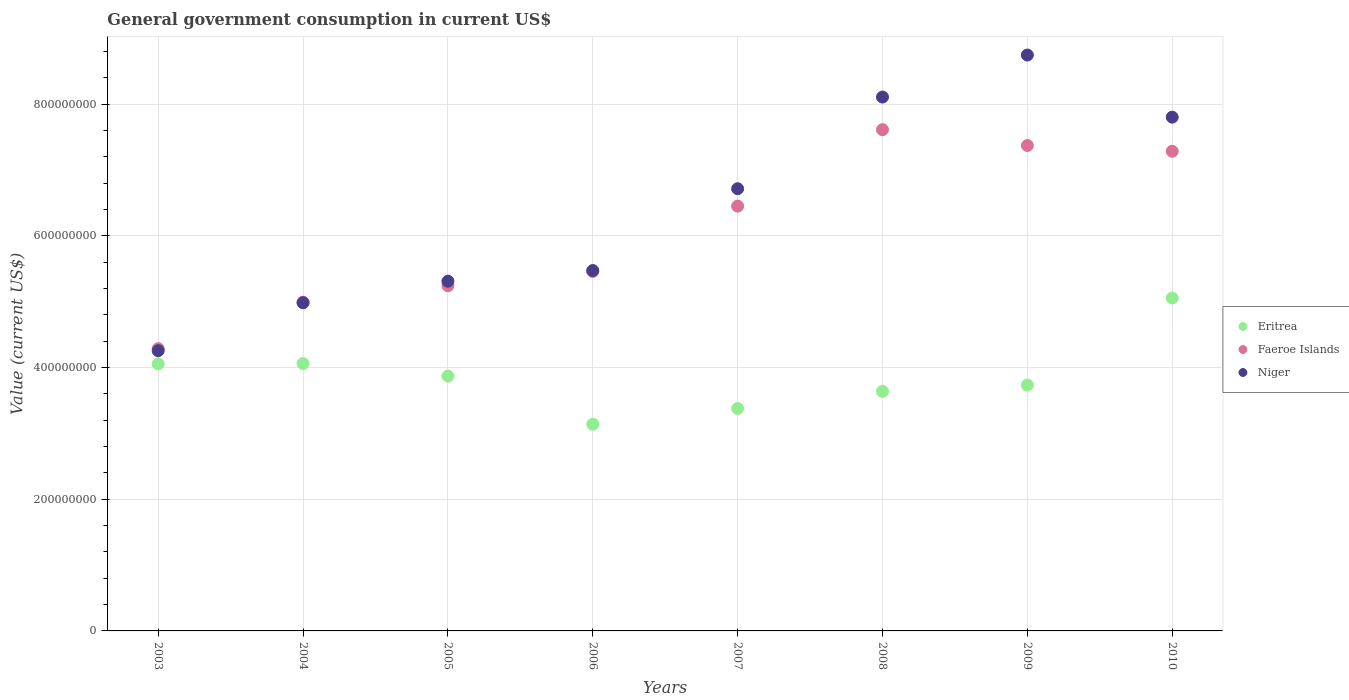Is the number of dotlines equal to the number of legend labels?
Your response must be concise. Yes. What is the government conusmption in Eritrea in 2005?
Provide a short and direct response. 3.87e+08. Across all years, what is the maximum government conusmption in Faeroe Islands?
Your response must be concise. 7.61e+08. Across all years, what is the minimum government conusmption in Eritrea?
Give a very brief answer. 3.14e+08. In which year was the government conusmption in Eritrea maximum?
Offer a terse response. 2010. In which year was the government conusmption in Faeroe Islands minimum?
Provide a succinct answer. 2003. What is the total government conusmption in Faeroe Islands in the graph?
Your response must be concise. 4.87e+09. What is the difference between the government conusmption in Niger in 2004 and that in 2008?
Keep it short and to the point. -3.12e+08. What is the difference between the government conusmption in Faeroe Islands in 2006 and the government conusmption in Niger in 2003?
Ensure brevity in your answer.  1.20e+08. What is the average government conusmption in Faeroe Islands per year?
Provide a short and direct response. 6.09e+08. In the year 2008, what is the difference between the government conusmption in Eritrea and government conusmption in Faeroe Islands?
Provide a succinct answer. -3.97e+08. In how many years, is the government conusmption in Niger greater than 320000000 US$?
Make the answer very short. 8. What is the ratio of the government conusmption in Niger in 2006 to that in 2008?
Make the answer very short. 0.68. What is the difference between the highest and the second highest government conusmption in Eritrea?
Provide a short and direct response. 9.95e+07. What is the difference between the highest and the lowest government conusmption in Niger?
Your answer should be very brief. 4.49e+08. In how many years, is the government conusmption in Eritrea greater than the average government conusmption in Eritrea taken over all years?
Give a very brief answer. 4. Is the sum of the government conusmption in Niger in 2003 and 2008 greater than the maximum government conusmption in Faeroe Islands across all years?
Offer a very short reply. Yes. Is the government conusmption in Faeroe Islands strictly greater than the government conusmption in Niger over the years?
Ensure brevity in your answer.  No. How many years are there in the graph?
Keep it short and to the point. 8. What is the difference between two consecutive major ticks on the Y-axis?
Provide a succinct answer. 2.00e+08. Are the values on the major ticks of Y-axis written in scientific E-notation?
Provide a succinct answer. No. Does the graph contain any zero values?
Offer a very short reply. No. How many legend labels are there?
Offer a very short reply. 3. What is the title of the graph?
Ensure brevity in your answer.  General government consumption in current US$. What is the label or title of the X-axis?
Make the answer very short. Years. What is the label or title of the Y-axis?
Offer a very short reply. Value (current US$). What is the Value (current US$) of Eritrea in 2003?
Keep it short and to the point. 4.06e+08. What is the Value (current US$) of Faeroe Islands in 2003?
Your answer should be very brief. 4.29e+08. What is the Value (current US$) of Niger in 2003?
Keep it short and to the point. 4.26e+08. What is the Value (current US$) of Eritrea in 2004?
Offer a terse response. 4.06e+08. What is the Value (current US$) of Faeroe Islands in 2004?
Offer a very short reply. 4.99e+08. What is the Value (current US$) of Niger in 2004?
Offer a very short reply. 4.98e+08. What is the Value (current US$) of Eritrea in 2005?
Provide a succinct answer. 3.87e+08. What is the Value (current US$) in Faeroe Islands in 2005?
Provide a short and direct response. 5.24e+08. What is the Value (current US$) in Niger in 2005?
Your answer should be very brief. 5.31e+08. What is the Value (current US$) in Eritrea in 2006?
Give a very brief answer. 3.14e+08. What is the Value (current US$) in Faeroe Islands in 2006?
Offer a terse response. 5.46e+08. What is the Value (current US$) in Niger in 2006?
Your answer should be very brief. 5.47e+08. What is the Value (current US$) in Eritrea in 2007?
Your answer should be compact. 3.38e+08. What is the Value (current US$) of Faeroe Islands in 2007?
Your answer should be very brief. 6.45e+08. What is the Value (current US$) in Niger in 2007?
Your answer should be compact. 6.72e+08. What is the Value (current US$) of Eritrea in 2008?
Your answer should be very brief. 3.64e+08. What is the Value (current US$) in Faeroe Islands in 2008?
Ensure brevity in your answer.  7.61e+08. What is the Value (current US$) in Niger in 2008?
Keep it short and to the point. 8.11e+08. What is the Value (current US$) in Eritrea in 2009?
Offer a very short reply. 3.73e+08. What is the Value (current US$) of Faeroe Islands in 2009?
Provide a short and direct response. 7.37e+08. What is the Value (current US$) in Niger in 2009?
Your response must be concise. 8.75e+08. What is the Value (current US$) in Eritrea in 2010?
Give a very brief answer. 5.06e+08. What is the Value (current US$) of Faeroe Islands in 2010?
Provide a succinct answer. 7.28e+08. What is the Value (current US$) in Niger in 2010?
Offer a terse response. 7.80e+08. Across all years, what is the maximum Value (current US$) of Eritrea?
Give a very brief answer. 5.06e+08. Across all years, what is the maximum Value (current US$) in Faeroe Islands?
Ensure brevity in your answer.  7.61e+08. Across all years, what is the maximum Value (current US$) of Niger?
Your answer should be compact. 8.75e+08. Across all years, what is the minimum Value (current US$) in Eritrea?
Offer a very short reply. 3.14e+08. Across all years, what is the minimum Value (current US$) in Faeroe Islands?
Your answer should be compact. 4.29e+08. Across all years, what is the minimum Value (current US$) in Niger?
Keep it short and to the point. 4.26e+08. What is the total Value (current US$) of Eritrea in the graph?
Your answer should be compact. 3.09e+09. What is the total Value (current US$) of Faeroe Islands in the graph?
Your answer should be compact. 4.87e+09. What is the total Value (current US$) of Niger in the graph?
Your answer should be very brief. 5.14e+09. What is the difference between the Value (current US$) in Eritrea in 2003 and that in 2004?
Give a very brief answer. -4.90e+05. What is the difference between the Value (current US$) of Faeroe Islands in 2003 and that in 2004?
Give a very brief answer. -7.06e+07. What is the difference between the Value (current US$) of Niger in 2003 and that in 2004?
Provide a short and direct response. -7.28e+07. What is the difference between the Value (current US$) in Eritrea in 2003 and that in 2005?
Offer a terse response. 1.85e+07. What is the difference between the Value (current US$) in Faeroe Islands in 2003 and that in 2005?
Provide a short and direct response. -9.56e+07. What is the difference between the Value (current US$) in Niger in 2003 and that in 2005?
Your response must be concise. -1.06e+08. What is the difference between the Value (current US$) in Eritrea in 2003 and that in 2006?
Offer a terse response. 9.16e+07. What is the difference between the Value (current US$) in Faeroe Islands in 2003 and that in 2006?
Your response must be concise. -1.17e+08. What is the difference between the Value (current US$) in Niger in 2003 and that in 2006?
Your answer should be very brief. -1.22e+08. What is the difference between the Value (current US$) of Eritrea in 2003 and that in 2007?
Provide a short and direct response. 6.77e+07. What is the difference between the Value (current US$) in Faeroe Islands in 2003 and that in 2007?
Provide a short and direct response. -2.16e+08. What is the difference between the Value (current US$) of Niger in 2003 and that in 2007?
Give a very brief answer. -2.46e+08. What is the difference between the Value (current US$) of Eritrea in 2003 and that in 2008?
Offer a terse response. 4.17e+07. What is the difference between the Value (current US$) in Faeroe Islands in 2003 and that in 2008?
Make the answer very short. -3.33e+08. What is the difference between the Value (current US$) in Niger in 2003 and that in 2008?
Your response must be concise. -3.85e+08. What is the difference between the Value (current US$) in Eritrea in 2003 and that in 2009?
Offer a terse response. 3.21e+07. What is the difference between the Value (current US$) in Faeroe Islands in 2003 and that in 2009?
Ensure brevity in your answer.  -3.09e+08. What is the difference between the Value (current US$) of Niger in 2003 and that in 2009?
Your response must be concise. -4.49e+08. What is the difference between the Value (current US$) of Eritrea in 2003 and that in 2010?
Offer a terse response. -1.00e+08. What is the difference between the Value (current US$) of Faeroe Islands in 2003 and that in 2010?
Give a very brief answer. -3.00e+08. What is the difference between the Value (current US$) in Niger in 2003 and that in 2010?
Offer a terse response. -3.55e+08. What is the difference between the Value (current US$) in Eritrea in 2004 and that in 2005?
Provide a succinct answer. 1.90e+07. What is the difference between the Value (current US$) of Faeroe Islands in 2004 and that in 2005?
Your answer should be compact. -2.50e+07. What is the difference between the Value (current US$) in Niger in 2004 and that in 2005?
Provide a succinct answer. -3.27e+07. What is the difference between the Value (current US$) in Eritrea in 2004 and that in 2006?
Ensure brevity in your answer.  9.21e+07. What is the difference between the Value (current US$) in Faeroe Islands in 2004 and that in 2006?
Your response must be concise. -4.68e+07. What is the difference between the Value (current US$) of Niger in 2004 and that in 2006?
Give a very brief answer. -4.89e+07. What is the difference between the Value (current US$) of Eritrea in 2004 and that in 2007?
Your response must be concise. 6.82e+07. What is the difference between the Value (current US$) in Faeroe Islands in 2004 and that in 2007?
Your answer should be compact. -1.46e+08. What is the difference between the Value (current US$) in Niger in 2004 and that in 2007?
Your response must be concise. -1.73e+08. What is the difference between the Value (current US$) in Eritrea in 2004 and that in 2008?
Offer a very short reply. 4.22e+07. What is the difference between the Value (current US$) of Faeroe Islands in 2004 and that in 2008?
Give a very brief answer. -2.62e+08. What is the difference between the Value (current US$) in Niger in 2004 and that in 2008?
Offer a terse response. -3.12e+08. What is the difference between the Value (current US$) in Eritrea in 2004 and that in 2009?
Provide a short and direct response. 3.26e+07. What is the difference between the Value (current US$) in Faeroe Islands in 2004 and that in 2009?
Your answer should be compact. -2.38e+08. What is the difference between the Value (current US$) in Niger in 2004 and that in 2009?
Your answer should be very brief. -3.76e+08. What is the difference between the Value (current US$) of Eritrea in 2004 and that in 2010?
Provide a short and direct response. -9.95e+07. What is the difference between the Value (current US$) in Faeroe Islands in 2004 and that in 2010?
Your response must be concise. -2.29e+08. What is the difference between the Value (current US$) of Niger in 2004 and that in 2010?
Provide a short and direct response. -2.82e+08. What is the difference between the Value (current US$) of Eritrea in 2005 and that in 2006?
Your response must be concise. 7.31e+07. What is the difference between the Value (current US$) of Faeroe Islands in 2005 and that in 2006?
Provide a short and direct response. -2.17e+07. What is the difference between the Value (current US$) of Niger in 2005 and that in 2006?
Keep it short and to the point. -1.62e+07. What is the difference between the Value (current US$) of Eritrea in 2005 and that in 2007?
Offer a very short reply. 4.92e+07. What is the difference between the Value (current US$) in Faeroe Islands in 2005 and that in 2007?
Ensure brevity in your answer.  -1.21e+08. What is the difference between the Value (current US$) of Niger in 2005 and that in 2007?
Make the answer very short. -1.40e+08. What is the difference between the Value (current US$) in Eritrea in 2005 and that in 2008?
Your answer should be very brief. 2.32e+07. What is the difference between the Value (current US$) of Faeroe Islands in 2005 and that in 2008?
Ensure brevity in your answer.  -2.37e+08. What is the difference between the Value (current US$) in Niger in 2005 and that in 2008?
Provide a succinct answer. -2.80e+08. What is the difference between the Value (current US$) in Eritrea in 2005 and that in 2009?
Ensure brevity in your answer.  1.36e+07. What is the difference between the Value (current US$) of Faeroe Islands in 2005 and that in 2009?
Ensure brevity in your answer.  -2.13e+08. What is the difference between the Value (current US$) in Niger in 2005 and that in 2009?
Provide a short and direct response. -3.43e+08. What is the difference between the Value (current US$) of Eritrea in 2005 and that in 2010?
Provide a short and direct response. -1.19e+08. What is the difference between the Value (current US$) in Faeroe Islands in 2005 and that in 2010?
Provide a short and direct response. -2.04e+08. What is the difference between the Value (current US$) in Niger in 2005 and that in 2010?
Keep it short and to the point. -2.49e+08. What is the difference between the Value (current US$) of Eritrea in 2006 and that in 2007?
Give a very brief answer. -2.39e+07. What is the difference between the Value (current US$) in Faeroe Islands in 2006 and that in 2007?
Your response must be concise. -9.91e+07. What is the difference between the Value (current US$) in Niger in 2006 and that in 2007?
Offer a terse response. -1.24e+08. What is the difference between the Value (current US$) in Eritrea in 2006 and that in 2008?
Your response must be concise. -4.99e+07. What is the difference between the Value (current US$) in Faeroe Islands in 2006 and that in 2008?
Provide a succinct answer. -2.15e+08. What is the difference between the Value (current US$) in Niger in 2006 and that in 2008?
Provide a short and direct response. -2.63e+08. What is the difference between the Value (current US$) in Eritrea in 2006 and that in 2009?
Your answer should be very brief. -5.95e+07. What is the difference between the Value (current US$) of Faeroe Islands in 2006 and that in 2009?
Provide a short and direct response. -1.91e+08. What is the difference between the Value (current US$) of Niger in 2006 and that in 2009?
Your response must be concise. -3.27e+08. What is the difference between the Value (current US$) of Eritrea in 2006 and that in 2010?
Your answer should be compact. -1.92e+08. What is the difference between the Value (current US$) of Faeroe Islands in 2006 and that in 2010?
Offer a very short reply. -1.82e+08. What is the difference between the Value (current US$) in Niger in 2006 and that in 2010?
Your answer should be compact. -2.33e+08. What is the difference between the Value (current US$) of Eritrea in 2007 and that in 2008?
Your answer should be very brief. -2.60e+07. What is the difference between the Value (current US$) in Faeroe Islands in 2007 and that in 2008?
Make the answer very short. -1.16e+08. What is the difference between the Value (current US$) of Niger in 2007 and that in 2008?
Provide a succinct answer. -1.39e+08. What is the difference between the Value (current US$) in Eritrea in 2007 and that in 2009?
Ensure brevity in your answer.  -3.56e+07. What is the difference between the Value (current US$) in Faeroe Islands in 2007 and that in 2009?
Offer a very short reply. -9.20e+07. What is the difference between the Value (current US$) in Niger in 2007 and that in 2009?
Offer a very short reply. -2.03e+08. What is the difference between the Value (current US$) in Eritrea in 2007 and that in 2010?
Keep it short and to the point. -1.68e+08. What is the difference between the Value (current US$) of Faeroe Islands in 2007 and that in 2010?
Provide a succinct answer. -8.33e+07. What is the difference between the Value (current US$) in Niger in 2007 and that in 2010?
Offer a very short reply. -1.09e+08. What is the difference between the Value (current US$) of Eritrea in 2008 and that in 2009?
Provide a succinct answer. -9.58e+06. What is the difference between the Value (current US$) in Faeroe Islands in 2008 and that in 2009?
Keep it short and to the point. 2.41e+07. What is the difference between the Value (current US$) of Niger in 2008 and that in 2009?
Give a very brief answer. -6.38e+07. What is the difference between the Value (current US$) in Eritrea in 2008 and that in 2010?
Give a very brief answer. -1.42e+08. What is the difference between the Value (current US$) in Faeroe Islands in 2008 and that in 2010?
Offer a terse response. 3.28e+07. What is the difference between the Value (current US$) in Niger in 2008 and that in 2010?
Offer a terse response. 3.05e+07. What is the difference between the Value (current US$) of Eritrea in 2009 and that in 2010?
Your response must be concise. -1.32e+08. What is the difference between the Value (current US$) in Faeroe Islands in 2009 and that in 2010?
Your answer should be very brief. 8.72e+06. What is the difference between the Value (current US$) of Niger in 2009 and that in 2010?
Offer a terse response. 9.44e+07. What is the difference between the Value (current US$) of Eritrea in 2003 and the Value (current US$) of Faeroe Islands in 2004?
Your answer should be compact. -9.37e+07. What is the difference between the Value (current US$) in Eritrea in 2003 and the Value (current US$) in Niger in 2004?
Ensure brevity in your answer.  -9.29e+07. What is the difference between the Value (current US$) of Faeroe Islands in 2003 and the Value (current US$) of Niger in 2004?
Ensure brevity in your answer.  -6.97e+07. What is the difference between the Value (current US$) in Eritrea in 2003 and the Value (current US$) in Faeroe Islands in 2005?
Provide a short and direct response. -1.19e+08. What is the difference between the Value (current US$) in Eritrea in 2003 and the Value (current US$) in Niger in 2005?
Provide a short and direct response. -1.26e+08. What is the difference between the Value (current US$) of Faeroe Islands in 2003 and the Value (current US$) of Niger in 2005?
Offer a terse response. -1.02e+08. What is the difference between the Value (current US$) in Eritrea in 2003 and the Value (current US$) in Faeroe Islands in 2006?
Your answer should be compact. -1.40e+08. What is the difference between the Value (current US$) in Eritrea in 2003 and the Value (current US$) in Niger in 2006?
Make the answer very short. -1.42e+08. What is the difference between the Value (current US$) of Faeroe Islands in 2003 and the Value (current US$) of Niger in 2006?
Keep it short and to the point. -1.19e+08. What is the difference between the Value (current US$) in Eritrea in 2003 and the Value (current US$) in Faeroe Islands in 2007?
Your answer should be very brief. -2.40e+08. What is the difference between the Value (current US$) of Eritrea in 2003 and the Value (current US$) of Niger in 2007?
Make the answer very short. -2.66e+08. What is the difference between the Value (current US$) in Faeroe Islands in 2003 and the Value (current US$) in Niger in 2007?
Offer a very short reply. -2.43e+08. What is the difference between the Value (current US$) in Eritrea in 2003 and the Value (current US$) in Faeroe Islands in 2008?
Your response must be concise. -3.56e+08. What is the difference between the Value (current US$) of Eritrea in 2003 and the Value (current US$) of Niger in 2008?
Your answer should be compact. -4.05e+08. What is the difference between the Value (current US$) of Faeroe Islands in 2003 and the Value (current US$) of Niger in 2008?
Provide a succinct answer. -3.82e+08. What is the difference between the Value (current US$) of Eritrea in 2003 and the Value (current US$) of Faeroe Islands in 2009?
Give a very brief answer. -3.32e+08. What is the difference between the Value (current US$) of Eritrea in 2003 and the Value (current US$) of Niger in 2009?
Keep it short and to the point. -4.69e+08. What is the difference between the Value (current US$) in Faeroe Islands in 2003 and the Value (current US$) in Niger in 2009?
Offer a very short reply. -4.46e+08. What is the difference between the Value (current US$) of Eritrea in 2003 and the Value (current US$) of Faeroe Islands in 2010?
Keep it short and to the point. -3.23e+08. What is the difference between the Value (current US$) in Eritrea in 2003 and the Value (current US$) in Niger in 2010?
Keep it short and to the point. -3.75e+08. What is the difference between the Value (current US$) in Faeroe Islands in 2003 and the Value (current US$) in Niger in 2010?
Keep it short and to the point. -3.52e+08. What is the difference between the Value (current US$) of Eritrea in 2004 and the Value (current US$) of Faeroe Islands in 2005?
Make the answer very short. -1.18e+08. What is the difference between the Value (current US$) in Eritrea in 2004 and the Value (current US$) in Niger in 2005?
Your response must be concise. -1.25e+08. What is the difference between the Value (current US$) of Faeroe Islands in 2004 and the Value (current US$) of Niger in 2005?
Offer a terse response. -3.19e+07. What is the difference between the Value (current US$) of Eritrea in 2004 and the Value (current US$) of Faeroe Islands in 2006?
Offer a terse response. -1.40e+08. What is the difference between the Value (current US$) of Eritrea in 2004 and the Value (current US$) of Niger in 2006?
Provide a short and direct response. -1.41e+08. What is the difference between the Value (current US$) of Faeroe Islands in 2004 and the Value (current US$) of Niger in 2006?
Make the answer very short. -4.81e+07. What is the difference between the Value (current US$) in Eritrea in 2004 and the Value (current US$) in Faeroe Islands in 2007?
Make the answer very short. -2.39e+08. What is the difference between the Value (current US$) of Eritrea in 2004 and the Value (current US$) of Niger in 2007?
Provide a short and direct response. -2.66e+08. What is the difference between the Value (current US$) of Faeroe Islands in 2004 and the Value (current US$) of Niger in 2007?
Your answer should be very brief. -1.72e+08. What is the difference between the Value (current US$) of Eritrea in 2004 and the Value (current US$) of Faeroe Islands in 2008?
Ensure brevity in your answer.  -3.55e+08. What is the difference between the Value (current US$) of Eritrea in 2004 and the Value (current US$) of Niger in 2008?
Offer a very short reply. -4.05e+08. What is the difference between the Value (current US$) of Faeroe Islands in 2004 and the Value (current US$) of Niger in 2008?
Ensure brevity in your answer.  -3.12e+08. What is the difference between the Value (current US$) in Eritrea in 2004 and the Value (current US$) in Faeroe Islands in 2009?
Keep it short and to the point. -3.31e+08. What is the difference between the Value (current US$) in Eritrea in 2004 and the Value (current US$) in Niger in 2009?
Keep it short and to the point. -4.69e+08. What is the difference between the Value (current US$) in Faeroe Islands in 2004 and the Value (current US$) in Niger in 2009?
Offer a very short reply. -3.75e+08. What is the difference between the Value (current US$) in Eritrea in 2004 and the Value (current US$) in Faeroe Islands in 2010?
Your answer should be very brief. -3.22e+08. What is the difference between the Value (current US$) in Eritrea in 2004 and the Value (current US$) in Niger in 2010?
Ensure brevity in your answer.  -3.74e+08. What is the difference between the Value (current US$) of Faeroe Islands in 2004 and the Value (current US$) of Niger in 2010?
Offer a terse response. -2.81e+08. What is the difference between the Value (current US$) of Eritrea in 2005 and the Value (current US$) of Faeroe Islands in 2006?
Your answer should be compact. -1.59e+08. What is the difference between the Value (current US$) in Eritrea in 2005 and the Value (current US$) in Niger in 2006?
Offer a terse response. -1.60e+08. What is the difference between the Value (current US$) in Faeroe Islands in 2005 and the Value (current US$) in Niger in 2006?
Your answer should be compact. -2.30e+07. What is the difference between the Value (current US$) in Eritrea in 2005 and the Value (current US$) in Faeroe Islands in 2007?
Provide a short and direct response. -2.58e+08. What is the difference between the Value (current US$) of Eritrea in 2005 and the Value (current US$) of Niger in 2007?
Your answer should be compact. -2.85e+08. What is the difference between the Value (current US$) of Faeroe Islands in 2005 and the Value (current US$) of Niger in 2007?
Provide a short and direct response. -1.47e+08. What is the difference between the Value (current US$) in Eritrea in 2005 and the Value (current US$) in Faeroe Islands in 2008?
Keep it short and to the point. -3.74e+08. What is the difference between the Value (current US$) of Eritrea in 2005 and the Value (current US$) of Niger in 2008?
Offer a terse response. -4.24e+08. What is the difference between the Value (current US$) in Faeroe Islands in 2005 and the Value (current US$) in Niger in 2008?
Your response must be concise. -2.87e+08. What is the difference between the Value (current US$) in Eritrea in 2005 and the Value (current US$) in Faeroe Islands in 2009?
Give a very brief answer. -3.50e+08. What is the difference between the Value (current US$) of Eritrea in 2005 and the Value (current US$) of Niger in 2009?
Give a very brief answer. -4.88e+08. What is the difference between the Value (current US$) of Faeroe Islands in 2005 and the Value (current US$) of Niger in 2009?
Ensure brevity in your answer.  -3.50e+08. What is the difference between the Value (current US$) of Eritrea in 2005 and the Value (current US$) of Faeroe Islands in 2010?
Keep it short and to the point. -3.41e+08. What is the difference between the Value (current US$) of Eritrea in 2005 and the Value (current US$) of Niger in 2010?
Offer a terse response. -3.93e+08. What is the difference between the Value (current US$) of Faeroe Islands in 2005 and the Value (current US$) of Niger in 2010?
Offer a terse response. -2.56e+08. What is the difference between the Value (current US$) of Eritrea in 2006 and the Value (current US$) of Faeroe Islands in 2007?
Your response must be concise. -3.31e+08. What is the difference between the Value (current US$) in Eritrea in 2006 and the Value (current US$) in Niger in 2007?
Offer a terse response. -3.58e+08. What is the difference between the Value (current US$) of Faeroe Islands in 2006 and the Value (current US$) of Niger in 2007?
Keep it short and to the point. -1.26e+08. What is the difference between the Value (current US$) of Eritrea in 2006 and the Value (current US$) of Faeroe Islands in 2008?
Your answer should be compact. -4.47e+08. What is the difference between the Value (current US$) in Eritrea in 2006 and the Value (current US$) in Niger in 2008?
Keep it short and to the point. -4.97e+08. What is the difference between the Value (current US$) of Faeroe Islands in 2006 and the Value (current US$) of Niger in 2008?
Ensure brevity in your answer.  -2.65e+08. What is the difference between the Value (current US$) of Eritrea in 2006 and the Value (current US$) of Faeroe Islands in 2009?
Offer a terse response. -4.23e+08. What is the difference between the Value (current US$) of Eritrea in 2006 and the Value (current US$) of Niger in 2009?
Your response must be concise. -5.61e+08. What is the difference between the Value (current US$) of Faeroe Islands in 2006 and the Value (current US$) of Niger in 2009?
Provide a short and direct response. -3.29e+08. What is the difference between the Value (current US$) in Eritrea in 2006 and the Value (current US$) in Faeroe Islands in 2010?
Give a very brief answer. -4.15e+08. What is the difference between the Value (current US$) of Eritrea in 2006 and the Value (current US$) of Niger in 2010?
Your answer should be compact. -4.66e+08. What is the difference between the Value (current US$) of Faeroe Islands in 2006 and the Value (current US$) of Niger in 2010?
Provide a succinct answer. -2.34e+08. What is the difference between the Value (current US$) in Eritrea in 2007 and the Value (current US$) in Faeroe Islands in 2008?
Ensure brevity in your answer.  -4.23e+08. What is the difference between the Value (current US$) of Eritrea in 2007 and the Value (current US$) of Niger in 2008?
Give a very brief answer. -4.73e+08. What is the difference between the Value (current US$) of Faeroe Islands in 2007 and the Value (current US$) of Niger in 2008?
Give a very brief answer. -1.66e+08. What is the difference between the Value (current US$) of Eritrea in 2007 and the Value (current US$) of Faeroe Islands in 2009?
Give a very brief answer. -3.99e+08. What is the difference between the Value (current US$) of Eritrea in 2007 and the Value (current US$) of Niger in 2009?
Your response must be concise. -5.37e+08. What is the difference between the Value (current US$) in Faeroe Islands in 2007 and the Value (current US$) in Niger in 2009?
Your answer should be very brief. -2.29e+08. What is the difference between the Value (current US$) in Eritrea in 2007 and the Value (current US$) in Faeroe Islands in 2010?
Your response must be concise. -3.91e+08. What is the difference between the Value (current US$) of Eritrea in 2007 and the Value (current US$) of Niger in 2010?
Ensure brevity in your answer.  -4.42e+08. What is the difference between the Value (current US$) of Faeroe Islands in 2007 and the Value (current US$) of Niger in 2010?
Provide a succinct answer. -1.35e+08. What is the difference between the Value (current US$) in Eritrea in 2008 and the Value (current US$) in Faeroe Islands in 2009?
Offer a terse response. -3.73e+08. What is the difference between the Value (current US$) of Eritrea in 2008 and the Value (current US$) of Niger in 2009?
Offer a terse response. -5.11e+08. What is the difference between the Value (current US$) in Faeroe Islands in 2008 and the Value (current US$) in Niger in 2009?
Your answer should be very brief. -1.13e+08. What is the difference between the Value (current US$) of Eritrea in 2008 and the Value (current US$) of Faeroe Islands in 2010?
Give a very brief answer. -3.65e+08. What is the difference between the Value (current US$) in Eritrea in 2008 and the Value (current US$) in Niger in 2010?
Your answer should be very brief. -4.16e+08. What is the difference between the Value (current US$) of Faeroe Islands in 2008 and the Value (current US$) of Niger in 2010?
Your response must be concise. -1.90e+07. What is the difference between the Value (current US$) in Eritrea in 2009 and the Value (current US$) in Faeroe Islands in 2010?
Ensure brevity in your answer.  -3.55e+08. What is the difference between the Value (current US$) in Eritrea in 2009 and the Value (current US$) in Niger in 2010?
Your answer should be compact. -4.07e+08. What is the difference between the Value (current US$) of Faeroe Islands in 2009 and the Value (current US$) of Niger in 2010?
Offer a terse response. -4.31e+07. What is the average Value (current US$) of Eritrea per year?
Keep it short and to the point. 3.87e+08. What is the average Value (current US$) of Faeroe Islands per year?
Make the answer very short. 6.09e+08. What is the average Value (current US$) of Niger per year?
Your answer should be compact. 6.42e+08. In the year 2003, what is the difference between the Value (current US$) of Eritrea and Value (current US$) of Faeroe Islands?
Provide a short and direct response. -2.31e+07. In the year 2003, what is the difference between the Value (current US$) in Eritrea and Value (current US$) in Niger?
Keep it short and to the point. -2.00e+07. In the year 2003, what is the difference between the Value (current US$) in Faeroe Islands and Value (current US$) in Niger?
Offer a very short reply. 3.09e+06. In the year 2004, what is the difference between the Value (current US$) of Eritrea and Value (current US$) of Faeroe Islands?
Make the answer very short. -9.32e+07. In the year 2004, what is the difference between the Value (current US$) of Eritrea and Value (current US$) of Niger?
Offer a very short reply. -9.24e+07. In the year 2004, what is the difference between the Value (current US$) in Faeroe Islands and Value (current US$) in Niger?
Offer a terse response. 8.35e+05. In the year 2005, what is the difference between the Value (current US$) in Eritrea and Value (current US$) in Faeroe Islands?
Your response must be concise. -1.37e+08. In the year 2005, what is the difference between the Value (current US$) of Eritrea and Value (current US$) of Niger?
Ensure brevity in your answer.  -1.44e+08. In the year 2005, what is the difference between the Value (current US$) in Faeroe Islands and Value (current US$) in Niger?
Your response must be concise. -6.85e+06. In the year 2006, what is the difference between the Value (current US$) in Eritrea and Value (current US$) in Faeroe Islands?
Make the answer very short. -2.32e+08. In the year 2006, what is the difference between the Value (current US$) in Eritrea and Value (current US$) in Niger?
Provide a succinct answer. -2.33e+08. In the year 2006, what is the difference between the Value (current US$) in Faeroe Islands and Value (current US$) in Niger?
Provide a succinct answer. -1.31e+06. In the year 2007, what is the difference between the Value (current US$) in Eritrea and Value (current US$) in Faeroe Islands?
Make the answer very short. -3.07e+08. In the year 2007, what is the difference between the Value (current US$) of Eritrea and Value (current US$) of Niger?
Provide a short and direct response. -3.34e+08. In the year 2007, what is the difference between the Value (current US$) of Faeroe Islands and Value (current US$) of Niger?
Make the answer very short. -2.64e+07. In the year 2008, what is the difference between the Value (current US$) in Eritrea and Value (current US$) in Faeroe Islands?
Provide a succinct answer. -3.97e+08. In the year 2008, what is the difference between the Value (current US$) in Eritrea and Value (current US$) in Niger?
Your response must be concise. -4.47e+08. In the year 2008, what is the difference between the Value (current US$) of Faeroe Islands and Value (current US$) of Niger?
Your answer should be compact. -4.95e+07. In the year 2009, what is the difference between the Value (current US$) in Eritrea and Value (current US$) in Faeroe Islands?
Provide a succinct answer. -3.64e+08. In the year 2009, what is the difference between the Value (current US$) of Eritrea and Value (current US$) of Niger?
Your response must be concise. -5.01e+08. In the year 2009, what is the difference between the Value (current US$) of Faeroe Islands and Value (current US$) of Niger?
Your response must be concise. -1.37e+08. In the year 2010, what is the difference between the Value (current US$) of Eritrea and Value (current US$) of Faeroe Islands?
Your answer should be very brief. -2.23e+08. In the year 2010, what is the difference between the Value (current US$) in Eritrea and Value (current US$) in Niger?
Keep it short and to the point. -2.75e+08. In the year 2010, what is the difference between the Value (current US$) in Faeroe Islands and Value (current US$) in Niger?
Ensure brevity in your answer.  -5.18e+07. What is the ratio of the Value (current US$) in Eritrea in 2003 to that in 2004?
Keep it short and to the point. 1. What is the ratio of the Value (current US$) of Faeroe Islands in 2003 to that in 2004?
Your answer should be compact. 0.86. What is the ratio of the Value (current US$) of Niger in 2003 to that in 2004?
Offer a very short reply. 0.85. What is the ratio of the Value (current US$) in Eritrea in 2003 to that in 2005?
Give a very brief answer. 1.05. What is the ratio of the Value (current US$) of Faeroe Islands in 2003 to that in 2005?
Offer a terse response. 0.82. What is the ratio of the Value (current US$) of Niger in 2003 to that in 2005?
Provide a succinct answer. 0.8. What is the ratio of the Value (current US$) in Eritrea in 2003 to that in 2006?
Your answer should be compact. 1.29. What is the ratio of the Value (current US$) in Faeroe Islands in 2003 to that in 2006?
Offer a terse response. 0.79. What is the ratio of the Value (current US$) in Niger in 2003 to that in 2006?
Offer a terse response. 0.78. What is the ratio of the Value (current US$) of Eritrea in 2003 to that in 2007?
Keep it short and to the point. 1.2. What is the ratio of the Value (current US$) of Faeroe Islands in 2003 to that in 2007?
Keep it short and to the point. 0.66. What is the ratio of the Value (current US$) of Niger in 2003 to that in 2007?
Give a very brief answer. 0.63. What is the ratio of the Value (current US$) in Eritrea in 2003 to that in 2008?
Give a very brief answer. 1.11. What is the ratio of the Value (current US$) of Faeroe Islands in 2003 to that in 2008?
Your answer should be very brief. 0.56. What is the ratio of the Value (current US$) in Niger in 2003 to that in 2008?
Ensure brevity in your answer.  0.52. What is the ratio of the Value (current US$) of Eritrea in 2003 to that in 2009?
Ensure brevity in your answer.  1.09. What is the ratio of the Value (current US$) of Faeroe Islands in 2003 to that in 2009?
Provide a short and direct response. 0.58. What is the ratio of the Value (current US$) of Niger in 2003 to that in 2009?
Provide a succinct answer. 0.49. What is the ratio of the Value (current US$) in Eritrea in 2003 to that in 2010?
Give a very brief answer. 0.8. What is the ratio of the Value (current US$) in Faeroe Islands in 2003 to that in 2010?
Offer a terse response. 0.59. What is the ratio of the Value (current US$) of Niger in 2003 to that in 2010?
Your answer should be compact. 0.55. What is the ratio of the Value (current US$) in Eritrea in 2004 to that in 2005?
Your answer should be compact. 1.05. What is the ratio of the Value (current US$) in Faeroe Islands in 2004 to that in 2005?
Provide a succinct answer. 0.95. What is the ratio of the Value (current US$) in Niger in 2004 to that in 2005?
Offer a terse response. 0.94. What is the ratio of the Value (current US$) in Eritrea in 2004 to that in 2006?
Keep it short and to the point. 1.29. What is the ratio of the Value (current US$) of Faeroe Islands in 2004 to that in 2006?
Keep it short and to the point. 0.91. What is the ratio of the Value (current US$) in Niger in 2004 to that in 2006?
Give a very brief answer. 0.91. What is the ratio of the Value (current US$) of Eritrea in 2004 to that in 2007?
Give a very brief answer. 1.2. What is the ratio of the Value (current US$) in Faeroe Islands in 2004 to that in 2007?
Offer a terse response. 0.77. What is the ratio of the Value (current US$) in Niger in 2004 to that in 2007?
Ensure brevity in your answer.  0.74. What is the ratio of the Value (current US$) in Eritrea in 2004 to that in 2008?
Offer a very short reply. 1.12. What is the ratio of the Value (current US$) in Faeroe Islands in 2004 to that in 2008?
Give a very brief answer. 0.66. What is the ratio of the Value (current US$) of Niger in 2004 to that in 2008?
Give a very brief answer. 0.61. What is the ratio of the Value (current US$) of Eritrea in 2004 to that in 2009?
Provide a short and direct response. 1.09. What is the ratio of the Value (current US$) of Faeroe Islands in 2004 to that in 2009?
Your answer should be very brief. 0.68. What is the ratio of the Value (current US$) in Niger in 2004 to that in 2009?
Your response must be concise. 0.57. What is the ratio of the Value (current US$) in Eritrea in 2004 to that in 2010?
Provide a short and direct response. 0.8. What is the ratio of the Value (current US$) in Faeroe Islands in 2004 to that in 2010?
Offer a terse response. 0.69. What is the ratio of the Value (current US$) in Niger in 2004 to that in 2010?
Your answer should be compact. 0.64. What is the ratio of the Value (current US$) in Eritrea in 2005 to that in 2006?
Offer a very short reply. 1.23. What is the ratio of the Value (current US$) in Faeroe Islands in 2005 to that in 2006?
Keep it short and to the point. 0.96. What is the ratio of the Value (current US$) in Niger in 2005 to that in 2006?
Provide a short and direct response. 0.97. What is the ratio of the Value (current US$) in Eritrea in 2005 to that in 2007?
Give a very brief answer. 1.15. What is the ratio of the Value (current US$) in Faeroe Islands in 2005 to that in 2007?
Offer a very short reply. 0.81. What is the ratio of the Value (current US$) in Niger in 2005 to that in 2007?
Offer a terse response. 0.79. What is the ratio of the Value (current US$) in Eritrea in 2005 to that in 2008?
Keep it short and to the point. 1.06. What is the ratio of the Value (current US$) of Faeroe Islands in 2005 to that in 2008?
Keep it short and to the point. 0.69. What is the ratio of the Value (current US$) in Niger in 2005 to that in 2008?
Offer a very short reply. 0.66. What is the ratio of the Value (current US$) of Eritrea in 2005 to that in 2009?
Give a very brief answer. 1.04. What is the ratio of the Value (current US$) in Faeroe Islands in 2005 to that in 2009?
Your response must be concise. 0.71. What is the ratio of the Value (current US$) in Niger in 2005 to that in 2009?
Provide a short and direct response. 0.61. What is the ratio of the Value (current US$) in Eritrea in 2005 to that in 2010?
Offer a terse response. 0.77. What is the ratio of the Value (current US$) in Faeroe Islands in 2005 to that in 2010?
Make the answer very short. 0.72. What is the ratio of the Value (current US$) in Niger in 2005 to that in 2010?
Keep it short and to the point. 0.68. What is the ratio of the Value (current US$) of Eritrea in 2006 to that in 2007?
Give a very brief answer. 0.93. What is the ratio of the Value (current US$) in Faeroe Islands in 2006 to that in 2007?
Offer a very short reply. 0.85. What is the ratio of the Value (current US$) in Niger in 2006 to that in 2007?
Provide a succinct answer. 0.81. What is the ratio of the Value (current US$) of Eritrea in 2006 to that in 2008?
Offer a very short reply. 0.86. What is the ratio of the Value (current US$) of Faeroe Islands in 2006 to that in 2008?
Provide a short and direct response. 0.72. What is the ratio of the Value (current US$) in Niger in 2006 to that in 2008?
Offer a terse response. 0.68. What is the ratio of the Value (current US$) in Eritrea in 2006 to that in 2009?
Offer a terse response. 0.84. What is the ratio of the Value (current US$) of Faeroe Islands in 2006 to that in 2009?
Offer a very short reply. 0.74. What is the ratio of the Value (current US$) in Niger in 2006 to that in 2009?
Your answer should be very brief. 0.63. What is the ratio of the Value (current US$) of Eritrea in 2006 to that in 2010?
Your answer should be compact. 0.62. What is the ratio of the Value (current US$) of Faeroe Islands in 2006 to that in 2010?
Offer a terse response. 0.75. What is the ratio of the Value (current US$) of Niger in 2006 to that in 2010?
Keep it short and to the point. 0.7. What is the ratio of the Value (current US$) in Faeroe Islands in 2007 to that in 2008?
Make the answer very short. 0.85. What is the ratio of the Value (current US$) in Niger in 2007 to that in 2008?
Your answer should be very brief. 0.83. What is the ratio of the Value (current US$) in Eritrea in 2007 to that in 2009?
Your answer should be very brief. 0.9. What is the ratio of the Value (current US$) of Faeroe Islands in 2007 to that in 2009?
Your answer should be very brief. 0.88. What is the ratio of the Value (current US$) in Niger in 2007 to that in 2009?
Give a very brief answer. 0.77. What is the ratio of the Value (current US$) in Eritrea in 2007 to that in 2010?
Ensure brevity in your answer.  0.67. What is the ratio of the Value (current US$) of Faeroe Islands in 2007 to that in 2010?
Your answer should be compact. 0.89. What is the ratio of the Value (current US$) in Niger in 2007 to that in 2010?
Provide a succinct answer. 0.86. What is the ratio of the Value (current US$) of Eritrea in 2008 to that in 2009?
Your answer should be very brief. 0.97. What is the ratio of the Value (current US$) in Faeroe Islands in 2008 to that in 2009?
Make the answer very short. 1.03. What is the ratio of the Value (current US$) in Niger in 2008 to that in 2009?
Keep it short and to the point. 0.93. What is the ratio of the Value (current US$) in Eritrea in 2008 to that in 2010?
Ensure brevity in your answer.  0.72. What is the ratio of the Value (current US$) in Faeroe Islands in 2008 to that in 2010?
Make the answer very short. 1.04. What is the ratio of the Value (current US$) in Niger in 2008 to that in 2010?
Provide a short and direct response. 1.04. What is the ratio of the Value (current US$) of Eritrea in 2009 to that in 2010?
Give a very brief answer. 0.74. What is the ratio of the Value (current US$) of Faeroe Islands in 2009 to that in 2010?
Make the answer very short. 1.01. What is the ratio of the Value (current US$) in Niger in 2009 to that in 2010?
Offer a terse response. 1.12. What is the difference between the highest and the second highest Value (current US$) of Eritrea?
Give a very brief answer. 9.95e+07. What is the difference between the highest and the second highest Value (current US$) of Faeroe Islands?
Make the answer very short. 2.41e+07. What is the difference between the highest and the second highest Value (current US$) of Niger?
Keep it short and to the point. 6.38e+07. What is the difference between the highest and the lowest Value (current US$) of Eritrea?
Offer a terse response. 1.92e+08. What is the difference between the highest and the lowest Value (current US$) of Faeroe Islands?
Give a very brief answer. 3.33e+08. What is the difference between the highest and the lowest Value (current US$) in Niger?
Offer a very short reply. 4.49e+08. 